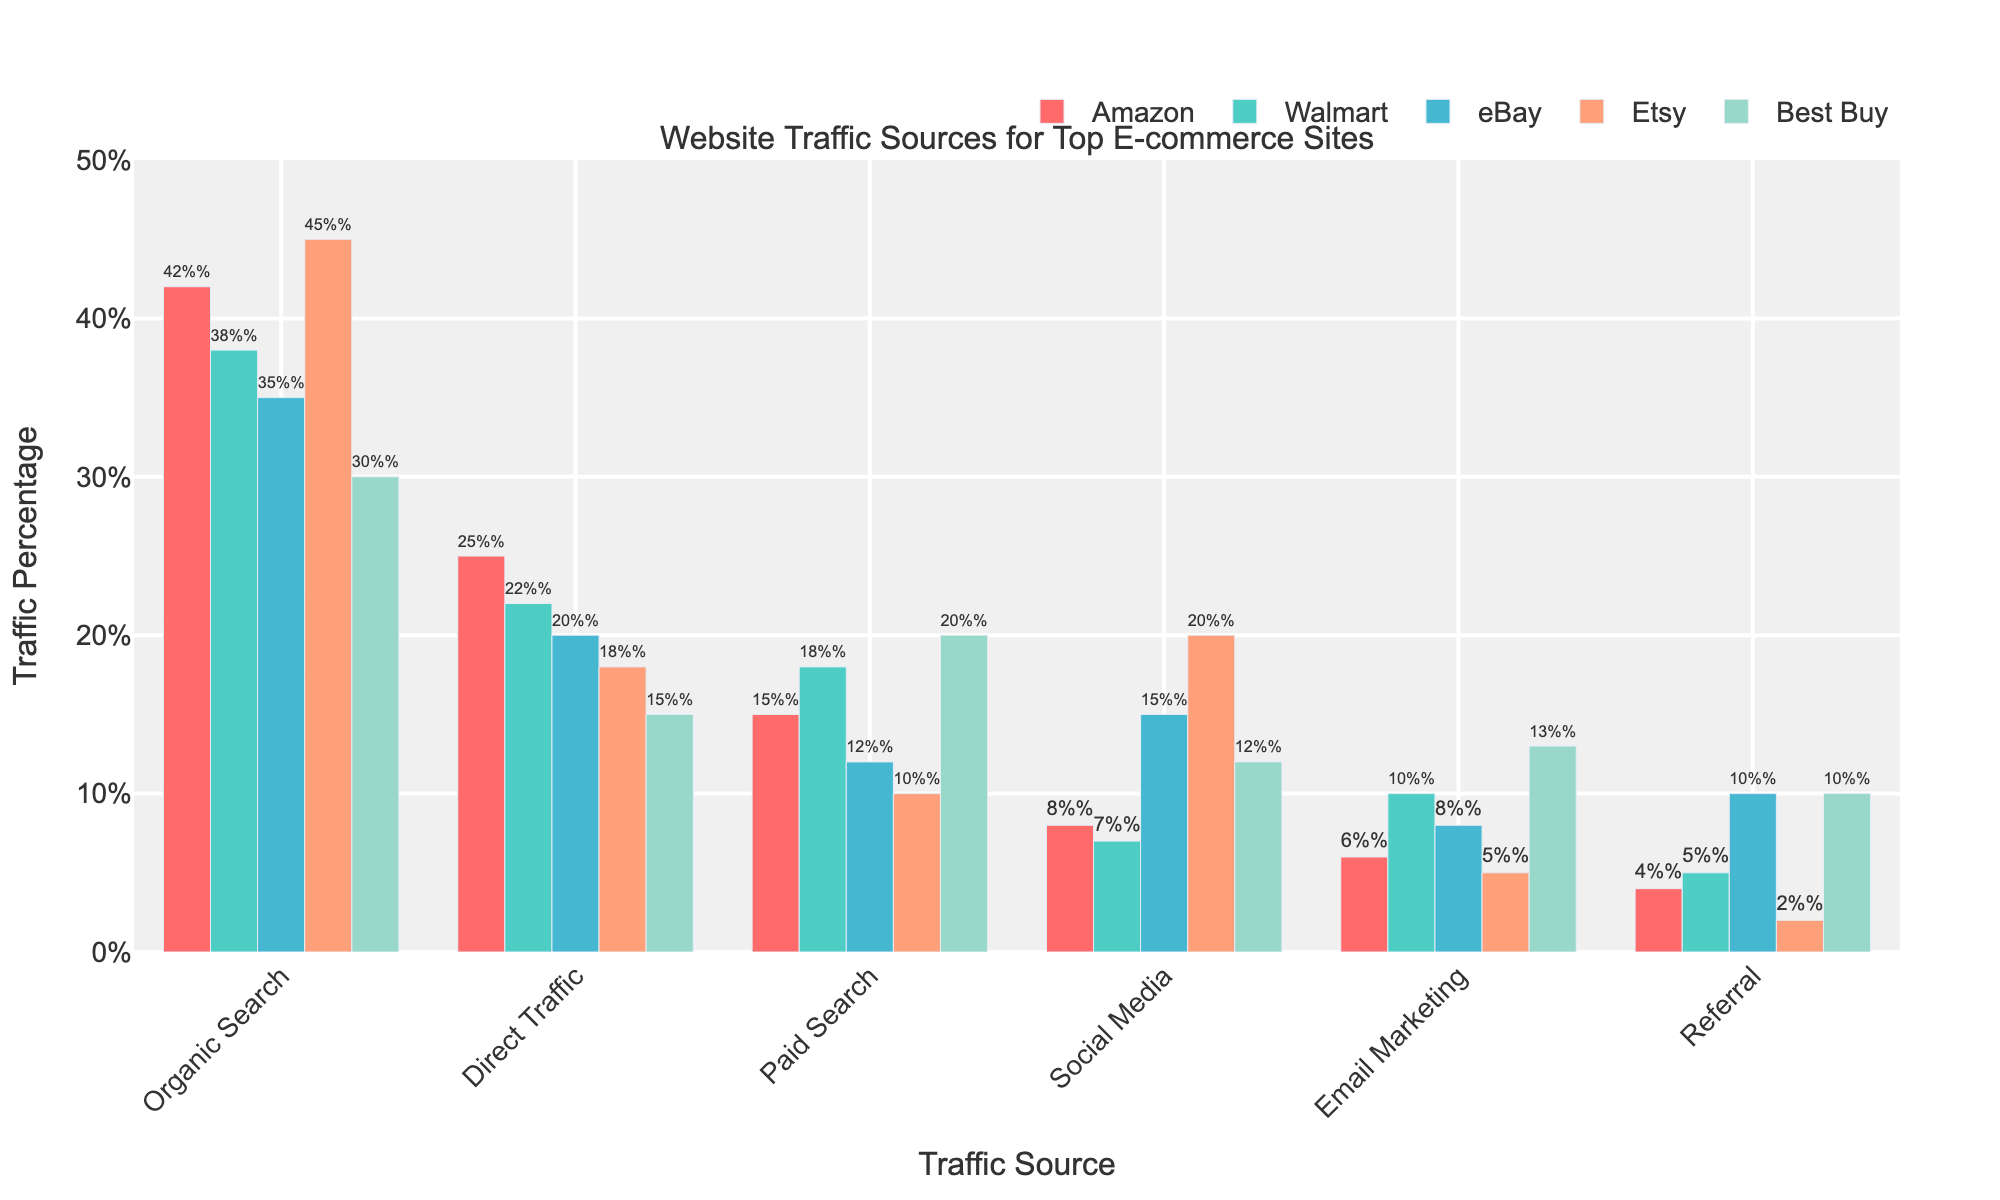Which channel contributes the least traffic to Etsy? Look at the bar representing Etsy for each channel, identify the shortest bar. The shortest bar is for Referral, with 2%.
Answer: Referral Which site gets the highest percentage of traffic from Paid Search? Compare the height of the bars for Paid Search across all sites. Best Buy has the tallest bar for Paid Search at 20%.
Answer: Best Buy How does the percentage of traffic from Social Media for eBay compare with that of Amazon? Examine the bars for Social Media for both eBay and Amazon. eBay has higher Social Media traffic at 15%, while Amazon has 8%.
Answer: eBay has more What is the total percentage of traffic from Organic Search across all sites? Sum the values of the bars for Organic Search for all sites: 42 (Amazon) + 38 (Walmart) + 35 (eBay) + 45 (Etsy) + 30 (Best Buy) = 190.
Answer: 190% Which site has the lowest percentage of Direct Traffic? Identify the shortest bar for Direct Traffic across all sites. Best Buy has the shortest bar at 15%.
Answer: Best Buy What is the average percentage of traffic from Email Marketing across all e-commerce sites? Sum the values for Email Marketing for all sites and divide by the number of sites: (6 + 10 + 8 + 5 + 13) / 5 = 42 / 5 = 8.4.
Answer: 8.4% Is the percentage of traffic from Referral higher for Best Buy or Walmart? Compare the height of the bars for Referral for both Best Buy and Walmart. Both have Referral traffic at 10%.
Answer: Equal Which site receives the highest percentage of Organic Search traffic? Identify the tallest bar for Organic Search. Etsy has the tallest bar at 45%.
Answer: Etsy What is the difference between the percentage of Direct Traffic and Social Media traffic for Walmart? Look at the bars for Direct Traffic and Social Media for Walmart: 22% (Direct Traffic) - 7% (Social Media) = 15%.
Answer: 15% What is the percentage increase in Email Marketing traffic from Amazon to Best Buy? Calculate the difference and then the percentage. Amazon's Email Marketing traffic is 6%, while Best Buy's is 13%. The increase is (13 - 6) = 7. The percentage increase is (7 / 6) * 100% ≈ 116.7%.
Answer: 116.7% 